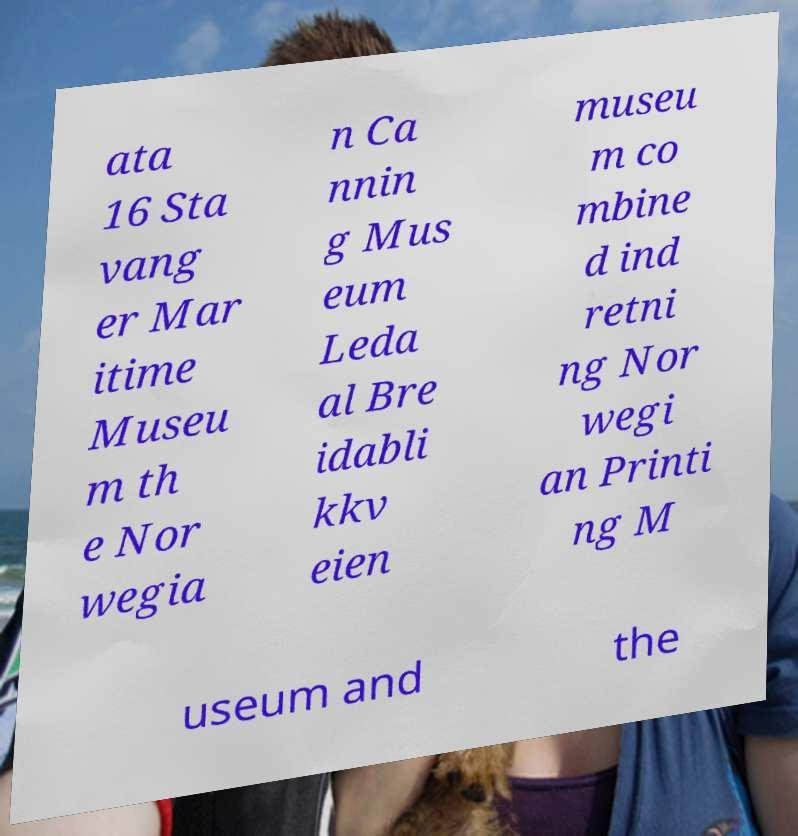For documentation purposes, I need the text within this image transcribed. Could you provide that? ata 16 Sta vang er Mar itime Museu m th e Nor wegia n Ca nnin g Mus eum Leda al Bre idabli kkv eien museu m co mbine d ind retni ng Nor wegi an Printi ng M useum and the 